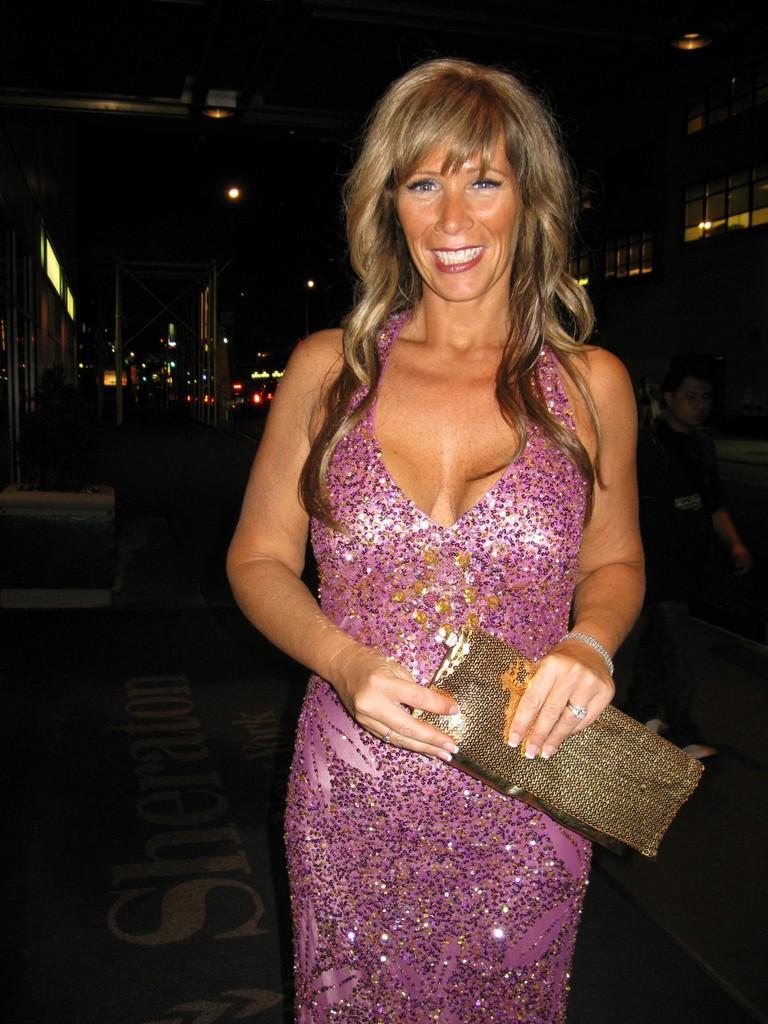Can you describe this image briefly? In the foreground of the picture I can see a woman holding the handbag in her hands and there is a smile on her face. There is a man on the right side. There is a lighting arrangement. I can see the glass windows on the top right side. In the background, I can see the scaffolding structure poles. 